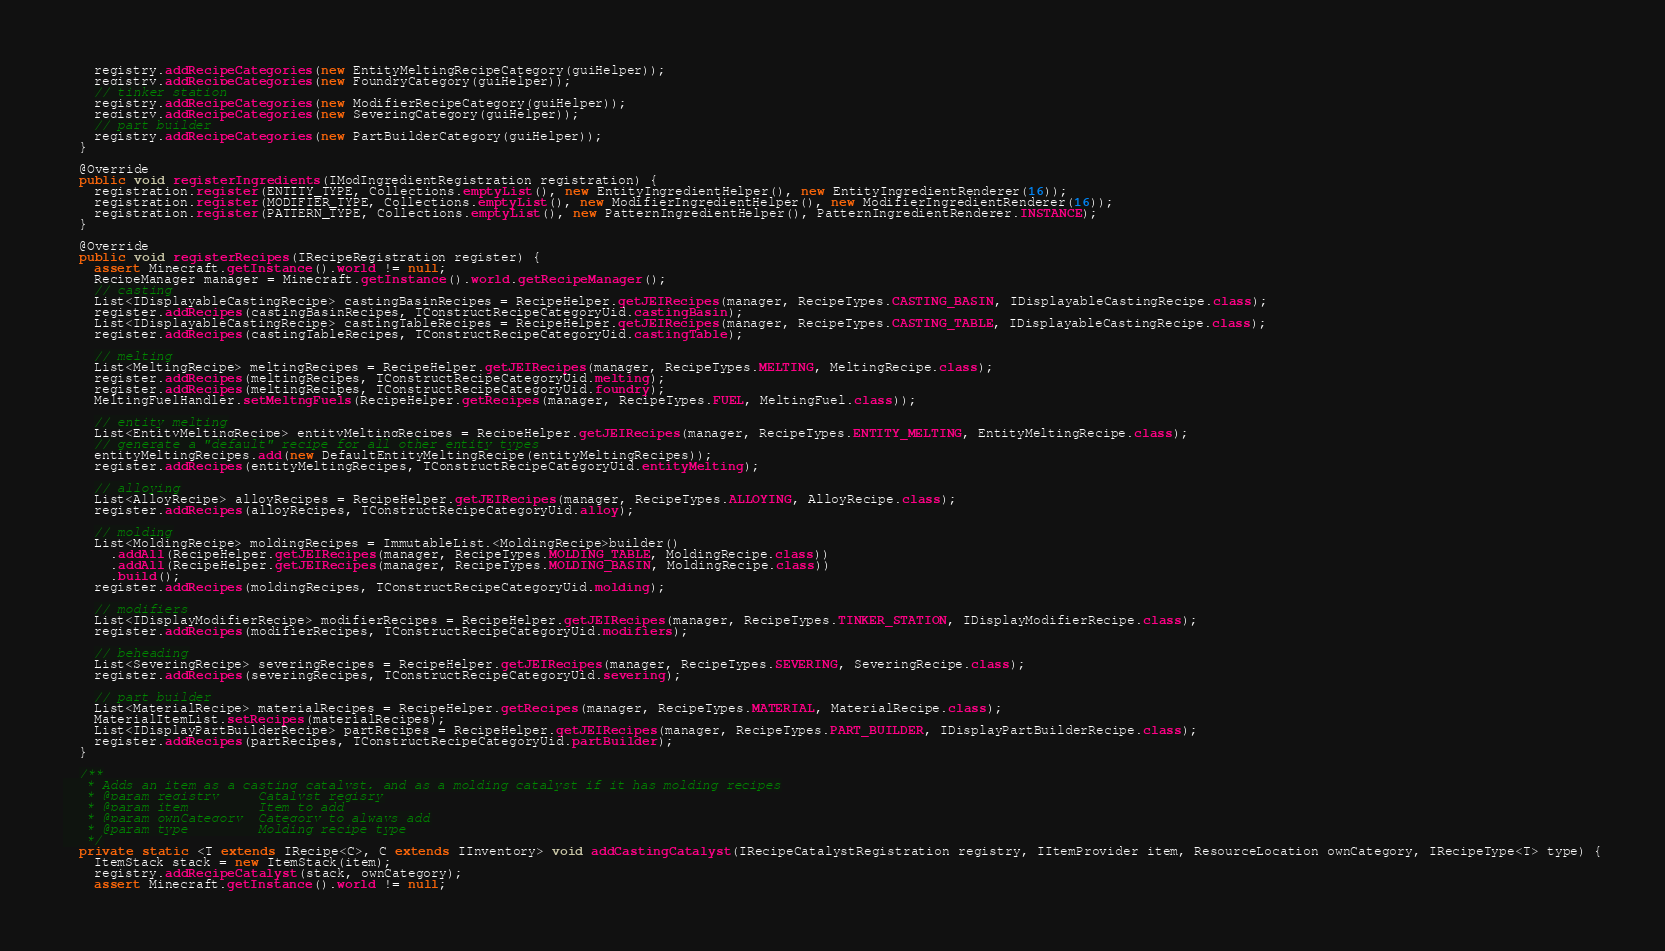<code> <loc_0><loc_0><loc_500><loc_500><_Java_>    registry.addRecipeCategories(new EntityMeltingRecipeCategory(guiHelper));
    registry.addRecipeCategories(new FoundryCategory(guiHelper));
    // tinker station
    registry.addRecipeCategories(new ModifierRecipeCategory(guiHelper));
    registry.addRecipeCategories(new SeveringCategory(guiHelper));
    // part builder
    registry.addRecipeCategories(new PartBuilderCategory(guiHelper));
  }

  @Override
  public void registerIngredients(IModIngredientRegistration registration) {
    registration.register(ENTITY_TYPE, Collections.emptyList(), new EntityIngredientHelper(), new EntityIngredientRenderer(16));
    registration.register(MODIFIER_TYPE, Collections.emptyList(), new ModifierIngredientHelper(), new ModifierIngredientRenderer(16));
    registration.register(PATTERN_TYPE, Collections.emptyList(), new PatternIngredientHelper(), PatternIngredientRenderer.INSTANCE);
  }

  @Override
  public void registerRecipes(IRecipeRegistration register) {
    assert Minecraft.getInstance().world != null;
    RecipeManager manager = Minecraft.getInstance().world.getRecipeManager();
    // casting
    List<IDisplayableCastingRecipe> castingBasinRecipes = RecipeHelper.getJEIRecipes(manager, RecipeTypes.CASTING_BASIN, IDisplayableCastingRecipe.class);
    register.addRecipes(castingBasinRecipes, TConstructRecipeCategoryUid.castingBasin);
    List<IDisplayableCastingRecipe> castingTableRecipes = RecipeHelper.getJEIRecipes(manager, RecipeTypes.CASTING_TABLE, IDisplayableCastingRecipe.class);
    register.addRecipes(castingTableRecipes, TConstructRecipeCategoryUid.castingTable);

    // melting
    List<MeltingRecipe> meltingRecipes = RecipeHelper.getJEIRecipes(manager, RecipeTypes.MELTING, MeltingRecipe.class);
    register.addRecipes(meltingRecipes, TConstructRecipeCategoryUid.melting);
    register.addRecipes(meltingRecipes, TConstructRecipeCategoryUid.foundry);
    MeltingFuelHandler.setMeltngFuels(RecipeHelper.getRecipes(manager, RecipeTypes.FUEL, MeltingFuel.class));

    // entity melting
    List<EntityMeltingRecipe> entityMeltingRecipes = RecipeHelper.getJEIRecipes(manager, RecipeTypes.ENTITY_MELTING, EntityMeltingRecipe.class);
    // generate a "default" recipe for all other entity types
    entityMeltingRecipes.add(new DefaultEntityMeltingRecipe(entityMeltingRecipes));
    register.addRecipes(entityMeltingRecipes, TConstructRecipeCategoryUid.entityMelting);

    // alloying
    List<AlloyRecipe> alloyRecipes = RecipeHelper.getJEIRecipes(manager, RecipeTypes.ALLOYING, AlloyRecipe.class);
    register.addRecipes(alloyRecipes, TConstructRecipeCategoryUid.alloy);

    // molding
    List<MoldingRecipe> moldingRecipes = ImmutableList.<MoldingRecipe>builder()
      .addAll(RecipeHelper.getJEIRecipes(manager, RecipeTypes.MOLDING_TABLE, MoldingRecipe.class))
      .addAll(RecipeHelper.getJEIRecipes(manager, RecipeTypes.MOLDING_BASIN, MoldingRecipe.class))
      .build();
    register.addRecipes(moldingRecipes, TConstructRecipeCategoryUid.molding);

    // modifiers
    List<IDisplayModifierRecipe> modifierRecipes = RecipeHelper.getJEIRecipes(manager, RecipeTypes.TINKER_STATION, IDisplayModifierRecipe.class);
    register.addRecipes(modifierRecipes, TConstructRecipeCategoryUid.modifiers);

    // beheading
    List<SeveringRecipe> severingRecipes = RecipeHelper.getJEIRecipes(manager, RecipeTypes.SEVERING, SeveringRecipe.class);
    register.addRecipes(severingRecipes, TConstructRecipeCategoryUid.severing);

    // part builder
    List<MaterialRecipe> materialRecipes = RecipeHelper.getRecipes(manager, RecipeTypes.MATERIAL, MaterialRecipe.class);
    MaterialItemList.setRecipes(materialRecipes);
    List<IDisplayPartBuilderRecipe> partRecipes = RecipeHelper.getJEIRecipes(manager, RecipeTypes.PART_BUILDER, IDisplayPartBuilderRecipe.class);
    register.addRecipes(partRecipes, TConstructRecipeCategoryUid.partBuilder);
  }

  /**
   * Adds an item as a casting catalyst, and as a molding catalyst if it has molding recipes
   * @param registry     Catalyst regisry
   * @param item         Item to add
   * @param ownCategory  Category to always add
   * @param type         Molding recipe type
   */
  private static <T extends IRecipe<C>, C extends IInventory> void addCastingCatalyst(IRecipeCatalystRegistration registry, IItemProvider item, ResourceLocation ownCategory, IRecipeType<T> type) {
    ItemStack stack = new ItemStack(item);
    registry.addRecipeCatalyst(stack, ownCategory);
    assert Minecraft.getInstance().world != null;</code> 